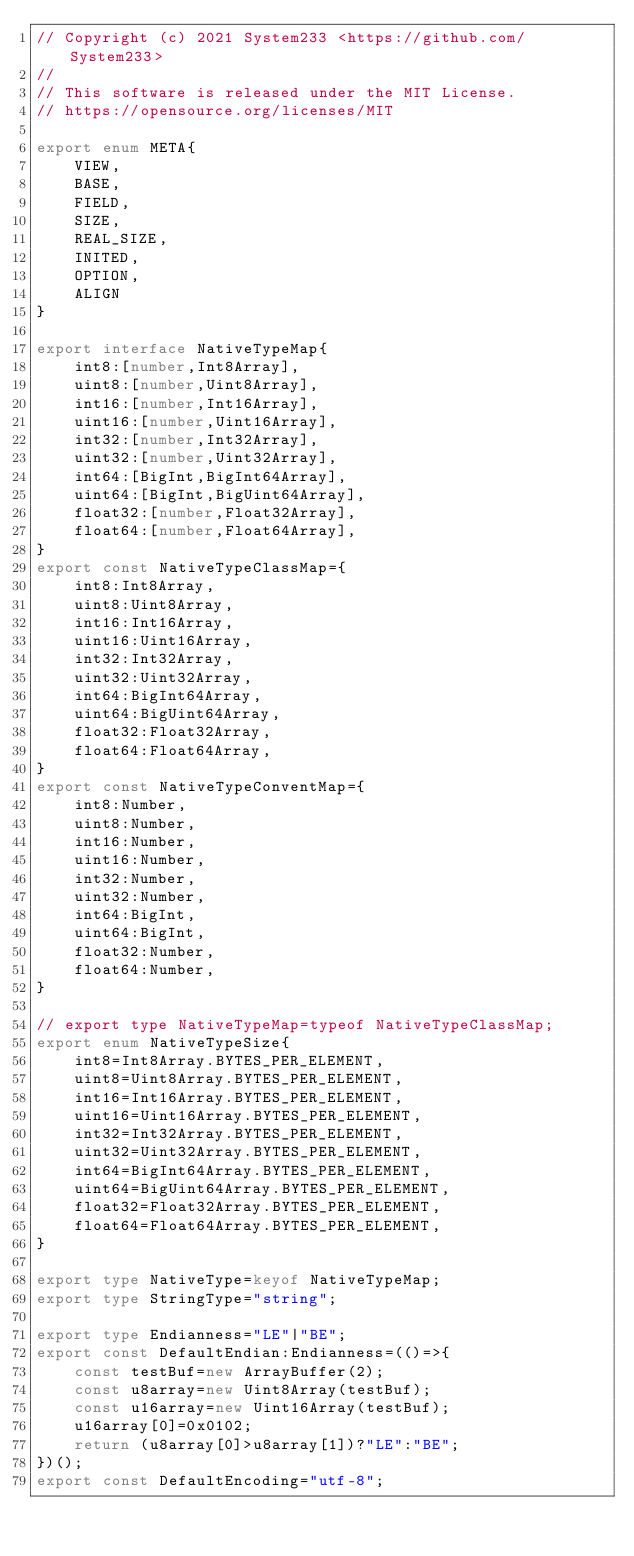Convert code to text. <code><loc_0><loc_0><loc_500><loc_500><_TypeScript_>// Copyright (c) 2021 System233 <https://github.com/System233>
// 
// This software is released under the MIT License.
// https://opensource.org/licenses/MIT

export enum META{
    VIEW,
    BASE,
    FIELD,
    SIZE,
    REAL_SIZE,
    INITED,
    OPTION,
    ALIGN
}

export interface NativeTypeMap{
    int8:[number,Int8Array],
    uint8:[number,Uint8Array],
    int16:[number,Int16Array],
    uint16:[number,Uint16Array],
    int32:[number,Int32Array],
    uint32:[number,Uint32Array],
    int64:[BigInt,BigInt64Array],
    uint64:[BigInt,BigUint64Array],
    float32:[number,Float32Array],
    float64:[number,Float64Array],
}
export const NativeTypeClassMap={
    int8:Int8Array,
    uint8:Uint8Array,
    int16:Int16Array,
    uint16:Uint16Array,
    int32:Int32Array,
    uint32:Uint32Array,
    int64:BigInt64Array,
    uint64:BigUint64Array,
    float32:Float32Array,
    float64:Float64Array,
}
export const NativeTypeConventMap={
    int8:Number,
    uint8:Number,
    int16:Number,
    uint16:Number,
    int32:Number,
    uint32:Number,
    int64:BigInt,
    uint64:BigInt,
    float32:Number,
    float64:Number,
}

// export type NativeTypeMap=typeof NativeTypeClassMap;
export enum NativeTypeSize{
    int8=Int8Array.BYTES_PER_ELEMENT,
    uint8=Uint8Array.BYTES_PER_ELEMENT,
    int16=Int16Array.BYTES_PER_ELEMENT,
    uint16=Uint16Array.BYTES_PER_ELEMENT,
    int32=Int32Array.BYTES_PER_ELEMENT,
    uint32=Uint32Array.BYTES_PER_ELEMENT,
    int64=BigInt64Array.BYTES_PER_ELEMENT,
    uint64=BigUint64Array.BYTES_PER_ELEMENT,
    float32=Float32Array.BYTES_PER_ELEMENT,
    float64=Float64Array.BYTES_PER_ELEMENT,
}

export type NativeType=keyof NativeTypeMap;
export type StringType="string";

export type Endianness="LE"|"BE";
export const DefaultEndian:Endianness=(()=>{
    const testBuf=new ArrayBuffer(2);
    const u8array=new Uint8Array(testBuf);
    const u16array=new Uint16Array(testBuf);
    u16array[0]=0x0102;
    return (u8array[0]>u8array[1])?"LE":"BE";
})();
export const DefaultEncoding="utf-8";</code> 